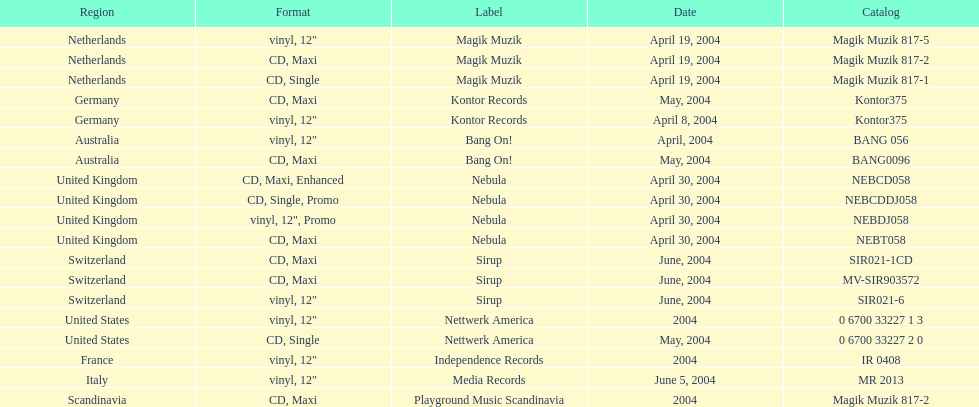What are the labels for love comes again? Magik Muzik, Magik Muzik, Magik Muzik, Kontor Records, Kontor Records, Bang On!, Bang On!, Nebula, Nebula, Nebula, Nebula, Sirup, Sirup, Sirup, Nettwerk America, Nettwerk America, Independence Records, Media Records, Playground Music Scandinavia. What label has been used by the region of france? Independence Records. 